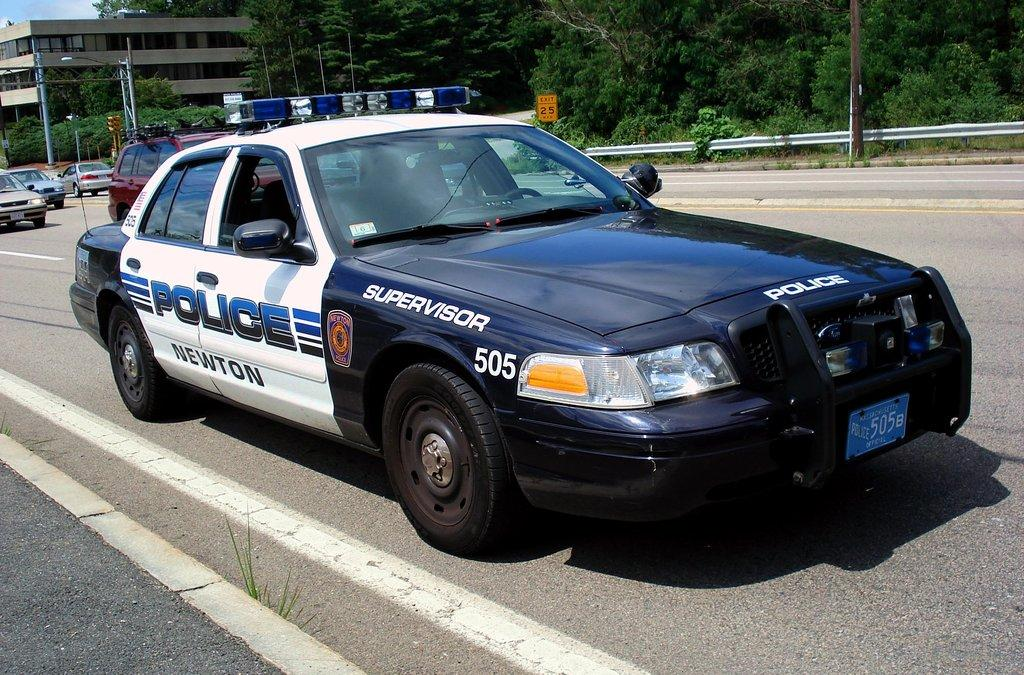What types of vehicles can be seen on the road in the image? There are vehicles on the road in the image. Can you identify any specific type of vehicle in the image? Yes, there is a police vehicle in the image. What is the source of light visible in the image? There is a light on a pole in the image. What type of barrier is present in the image? There is a fence in the image. What type of vegetation is visible in the image? There are trees in the image. What type of structure is present in the image? There is a building in the image. What can be seen in the sky in the image? There are clouds in the sky in the image. What type of pie is being served at the picnic in the image? There is no picnic or pie present in the image. How many sticks are being used to hold up the tent in the image? There is no tent or sticks present in the image. 